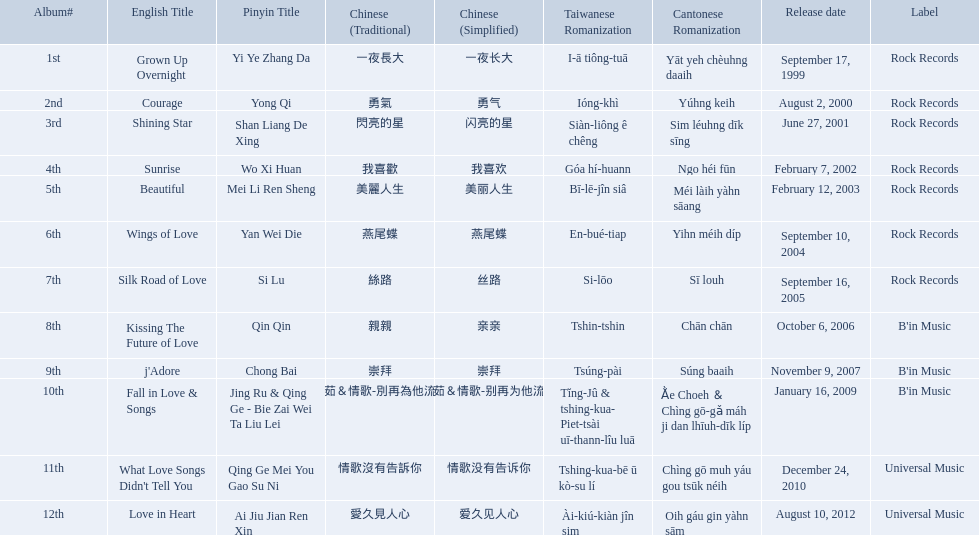Which songs did b'in music produce? Kissing The Future of Love, j'Adore, Fall in Love & Songs. Which one was released in an even numbered year? Kissing The Future of Love. 